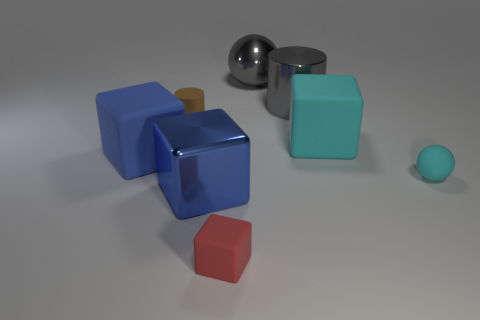Subtract all big metal cubes. How many cubes are left? 3 Add 1 yellow shiny spheres. How many objects exist? 9 Subtract all cyan spheres. How many spheres are left? 1 Subtract all cylinders. How many objects are left? 6 Subtract all red spheres. Subtract all yellow cubes. How many spheres are left? 2 Subtract all brown balls. How many gray cylinders are left? 1 Add 6 green matte cubes. How many green matte cubes exist? 6 Subtract 0 red spheres. How many objects are left? 8 Subtract 2 blocks. How many blocks are left? 2 Subtract all large gray things. Subtract all big matte objects. How many objects are left? 4 